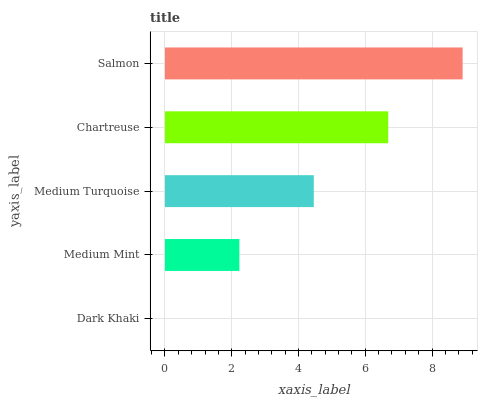Is Dark Khaki the minimum?
Answer yes or no. Yes. Is Salmon the maximum?
Answer yes or no. Yes. Is Medium Mint the minimum?
Answer yes or no. No. Is Medium Mint the maximum?
Answer yes or no. No. Is Medium Mint greater than Dark Khaki?
Answer yes or no. Yes. Is Dark Khaki less than Medium Mint?
Answer yes or no. Yes. Is Dark Khaki greater than Medium Mint?
Answer yes or no. No. Is Medium Mint less than Dark Khaki?
Answer yes or no. No. Is Medium Turquoise the high median?
Answer yes or no. Yes. Is Medium Turquoise the low median?
Answer yes or no. Yes. Is Salmon the high median?
Answer yes or no. No. Is Salmon the low median?
Answer yes or no. No. 